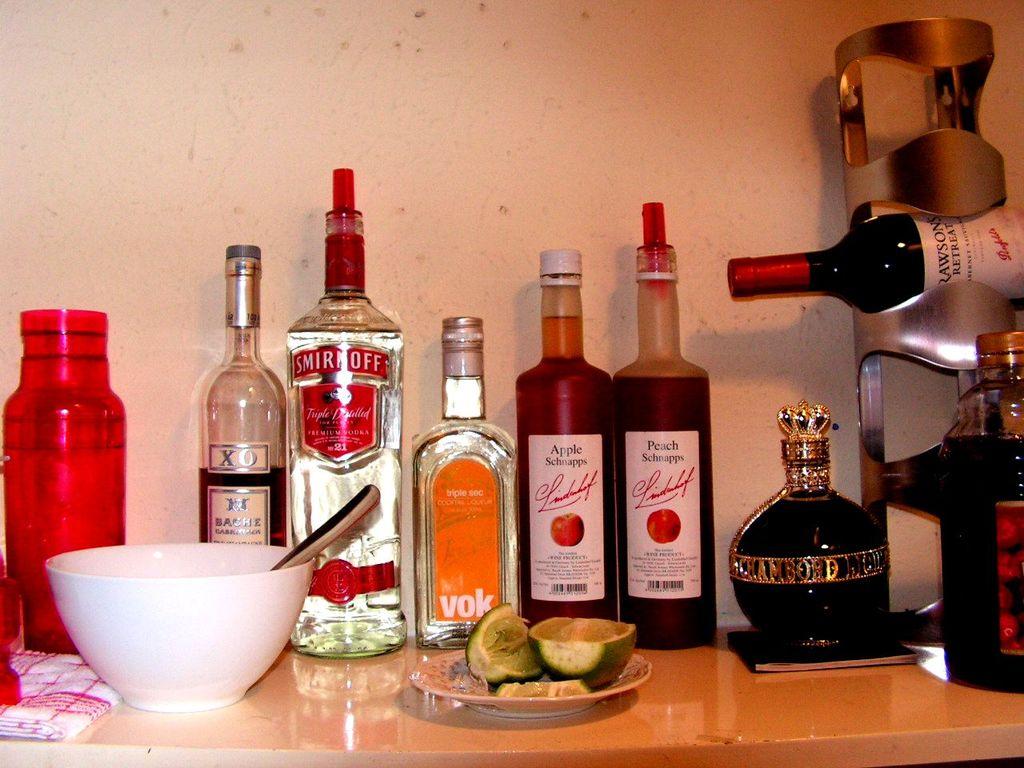What brand of alcohol is on this table?
Offer a terse response. Smirnoff. Is there apple schnapps on the table?
Offer a very short reply. Yes. 